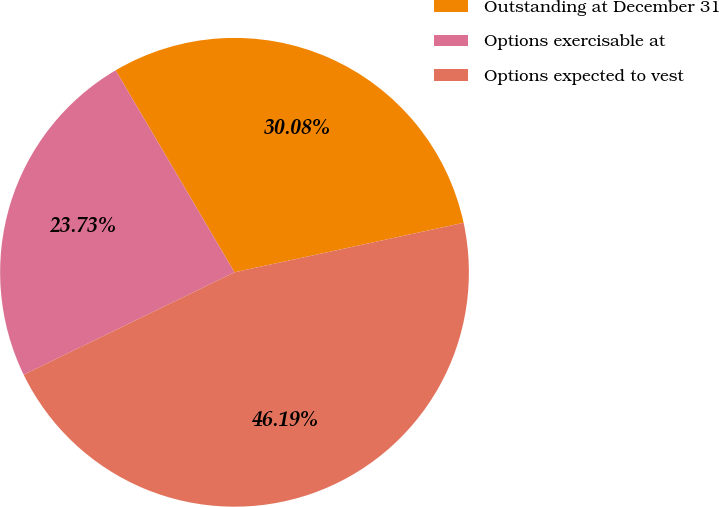Convert chart to OTSL. <chart><loc_0><loc_0><loc_500><loc_500><pie_chart><fcel>Outstanding at December 31<fcel>Options exercisable at<fcel>Options expected to vest<nl><fcel>30.08%<fcel>23.73%<fcel>46.19%<nl></chart> 